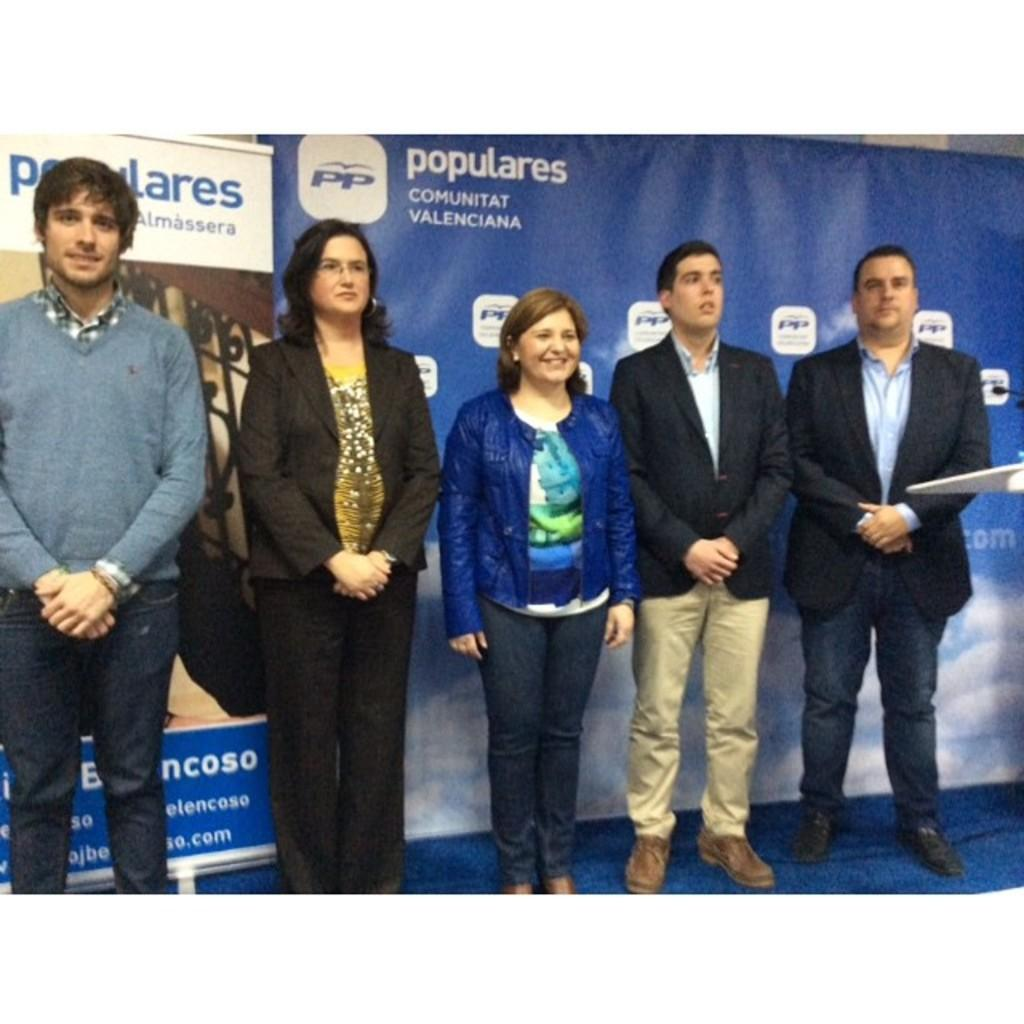What is happening in the center of the image? There are people standing on the stage in the center of the image. What can be seen behind the people on the stage? There are banners behind the people on the stage. Where is the podium located in the image? The podium is on the right side of the image. What is on the podium? There is a microphone (mic) on the podium. What type of riddle is being presented on the stage in the image? There is no riddle present in the image; it features people standing on a stage with banners and a podium with a microphone. What type of approval or support is being given to the people on the stage in the image? There is no indication of approval or support being given in the image; it simply shows people on a stage with banners and a podium with a microphone. 